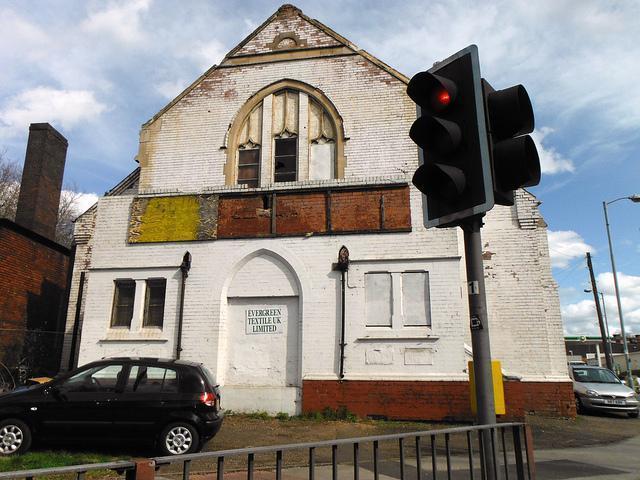How many traffic lights can be seen?
Give a very brief answer. 2. How many cars can you see?
Give a very brief answer. 2. 